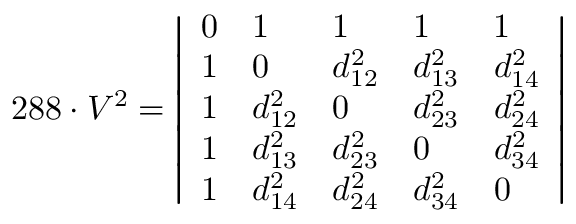Convert formula to latex. <formula><loc_0><loc_0><loc_500><loc_500>2 8 8 \cdot V ^ { 2 } = { \left | \begin{array} { l l l l l } { 0 } & { 1 } & { 1 } & { 1 } & { 1 } \\ { 1 } & { 0 } & { d _ { 1 2 } ^ { 2 } } & { d _ { 1 3 } ^ { 2 } } & { d _ { 1 4 } ^ { 2 } } \\ { 1 } & { d _ { 1 2 } ^ { 2 } } & { 0 } & { d _ { 2 3 } ^ { 2 } } & { d _ { 2 4 } ^ { 2 } } \\ { 1 } & { d _ { 1 3 } ^ { 2 } } & { d _ { 2 3 } ^ { 2 } } & { 0 } & { d _ { 3 4 } ^ { 2 } } \\ { 1 } & { d _ { 1 4 } ^ { 2 } } & { d _ { 2 4 } ^ { 2 } } & { d _ { 3 4 } ^ { 2 } } & { 0 } \end{array} \right | }</formula> 